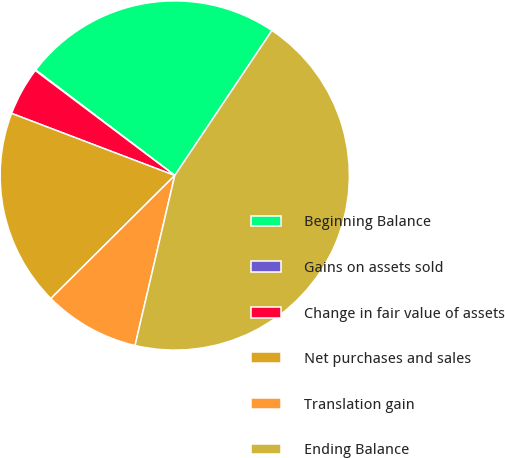<chart> <loc_0><loc_0><loc_500><loc_500><pie_chart><fcel>Beginning Balance<fcel>Gains on assets sold<fcel>Change in fair value of assets<fcel>Net purchases and sales<fcel>Translation gain<fcel>Ending Balance<nl><fcel>24.07%<fcel>0.06%<fcel>4.48%<fcel>18.23%<fcel>8.9%<fcel>44.25%<nl></chart> 